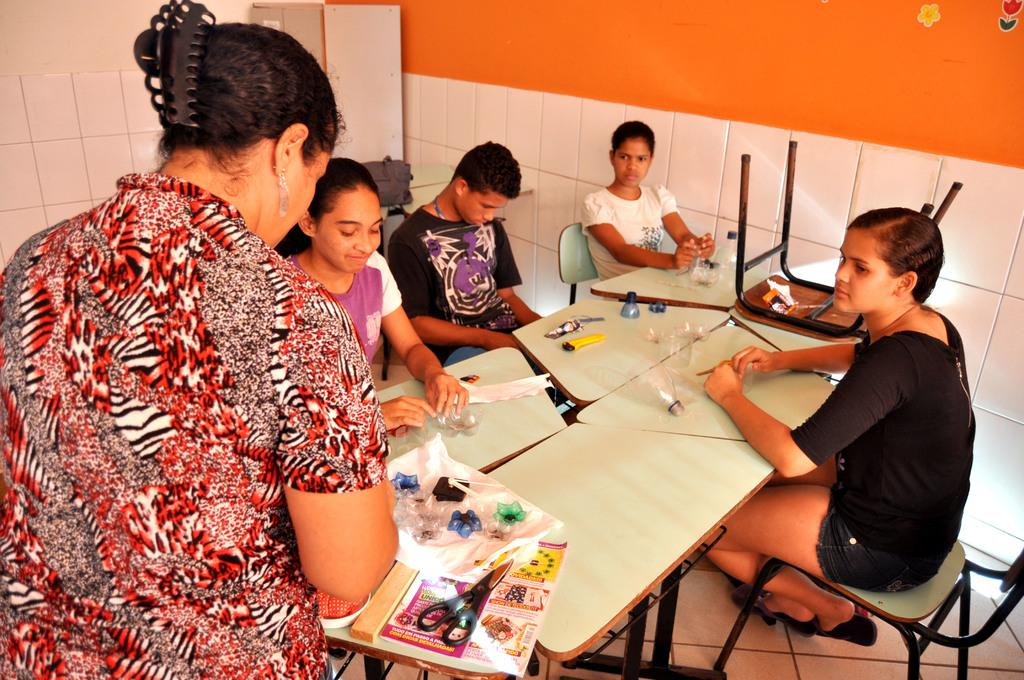How many people are in the image? There is a group of people in the image. What are the people doing in the image? The people are sitting at a table. What are the people holding in their hands? The people are holding objects, including scissors and decorative stuff. How many brothers are sitting at the table in the image? There is no mention of brothers in the image; it only states that there is a group of people sitting at a table. What type of tree can be seen growing through the table in the image? There is no tree present in the image; it only shows a group of people sitting at a table with objects in their hands. 